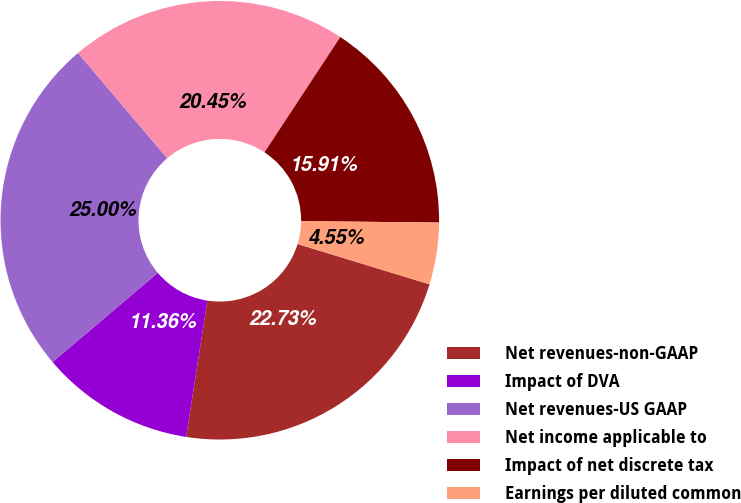<chart> <loc_0><loc_0><loc_500><loc_500><pie_chart><fcel>Net revenues-non-GAAP<fcel>Impact of DVA<fcel>Net revenues-US GAAP<fcel>Net income applicable to<fcel>Impact of net discrete tax<fcel>Earnings per diluted common<nl><fcel>22.73%<fcel>11.36%<fcel>25.0%<fcel>20.45%<fcel>15.91%<fcel>4.55%<nl></chart> 